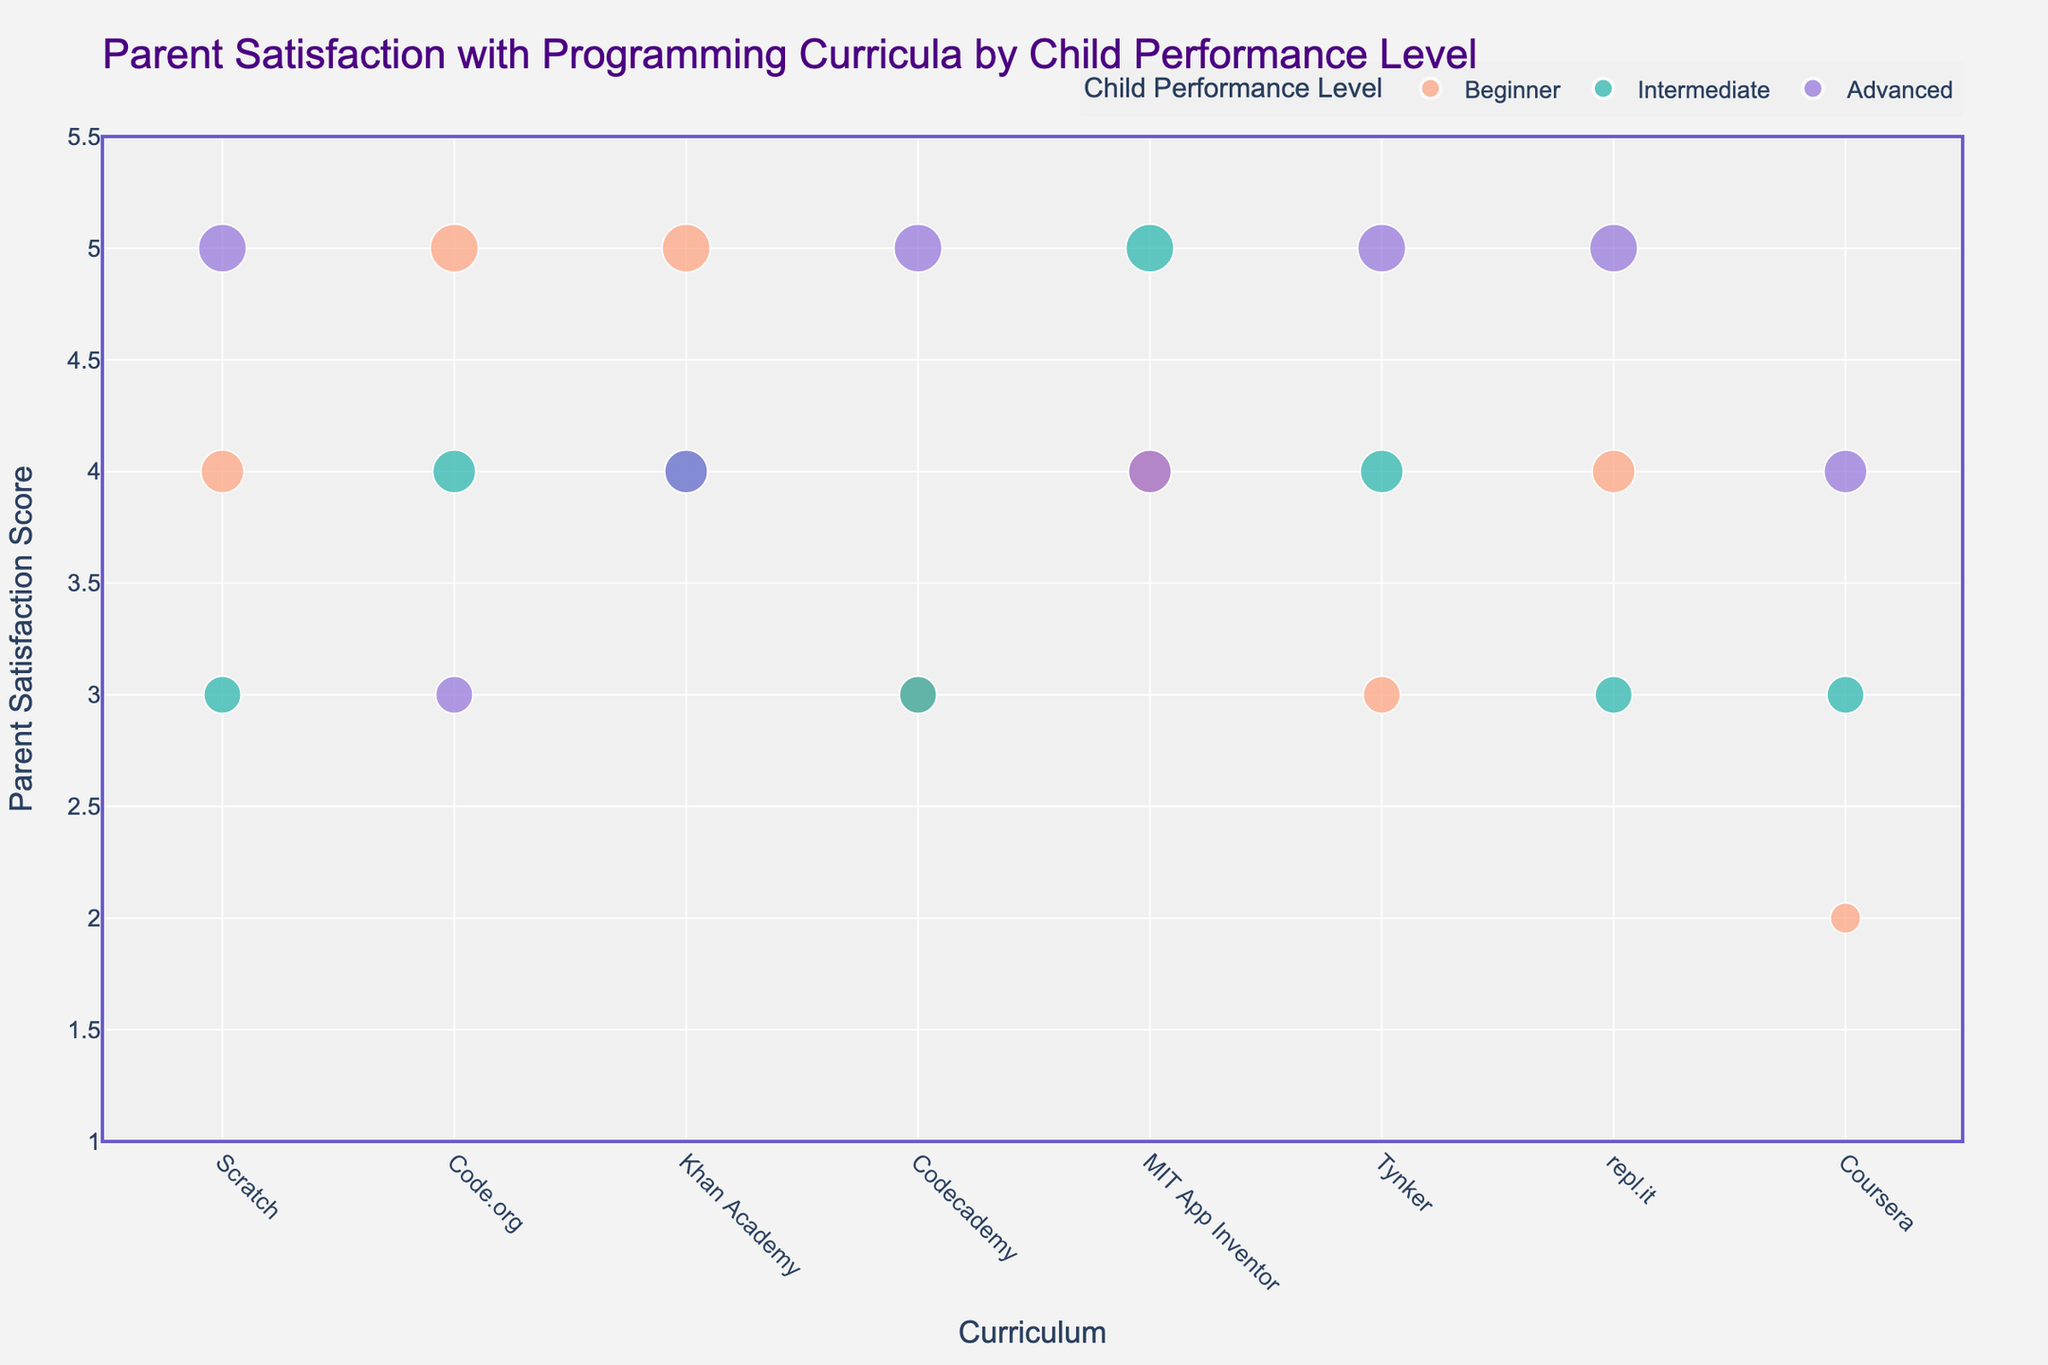What is the title of the figure? The title of the figure is usually placed at the top center of a plot. It gives a brief summary of what the figure represents. Here, the title can be found and read directly.
Answer: Parent Satisfaction with Programming Curricula by Child Performance Level How is the 'Child Performance Level' represented in the plot? In a grouped scatter plot, there are often visual cues like colors to distinguish between different groups. Here, 'Child Performance Level' is represented using distinct color codes for 'Beginner', 'Intermediate', and 'Advanced'.
Answer: By different colors Which curriculum has the highest parent satisfaction for beginners? To answer this, locate the 'Parent Satisfaction' values for 'Beginner' (colored specifically) across different curricula. The highest satisfaction score for beginners can be identified visually.
Answer: Code.org and Khan Academy (score of 5) How many data points are there in total? Each curriculum has three data points corresponding to Beginner, Intermediate, and Advanced levels. Count the total number of data points.
Answer: 24 Which curriculum has the lowest parent satisfaction for intermediate students? Find the 'Intermediate' data points (specific color) and compare their 'Parent Satisfaction' scores across all curricula. The lowest score can be identified.
Answer: repl.it (score of 3) What is the average parent satisfaction score for MIT App Inventor across all performance levels? Find and sum the parent satisfaction scores for MIT App Inventor across 'Beginner', 'Intermediate', and 'Advanced'. Divide the total by the number of performance levels (3) to get the average.
Answer: (4 + 5 + 4) / 3 = 4.33 Which curriculum shows the most consistency in parent satisfaction across all performance levels? Look for the curricula where parent satisfaction scores are close to each other irrespective of the performance levels, indicating consistency. Calculate the variation if needed.
Answer: Khan Academy (scores of 5, 4, 4) Between Scratch and Codecademy, which has a higher overall parent satisfaction for advanced students? Compare the 'Advanced' parent satisfaction scores for both Scratch and Codecademy directly.
Answer: Scratch (score of 5) 